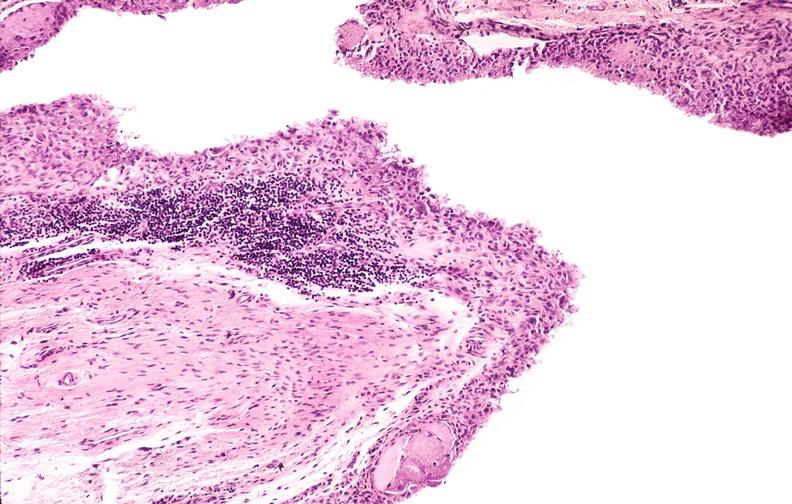s oil wrights cells present?
Answer the question using a single word or phrase. No 